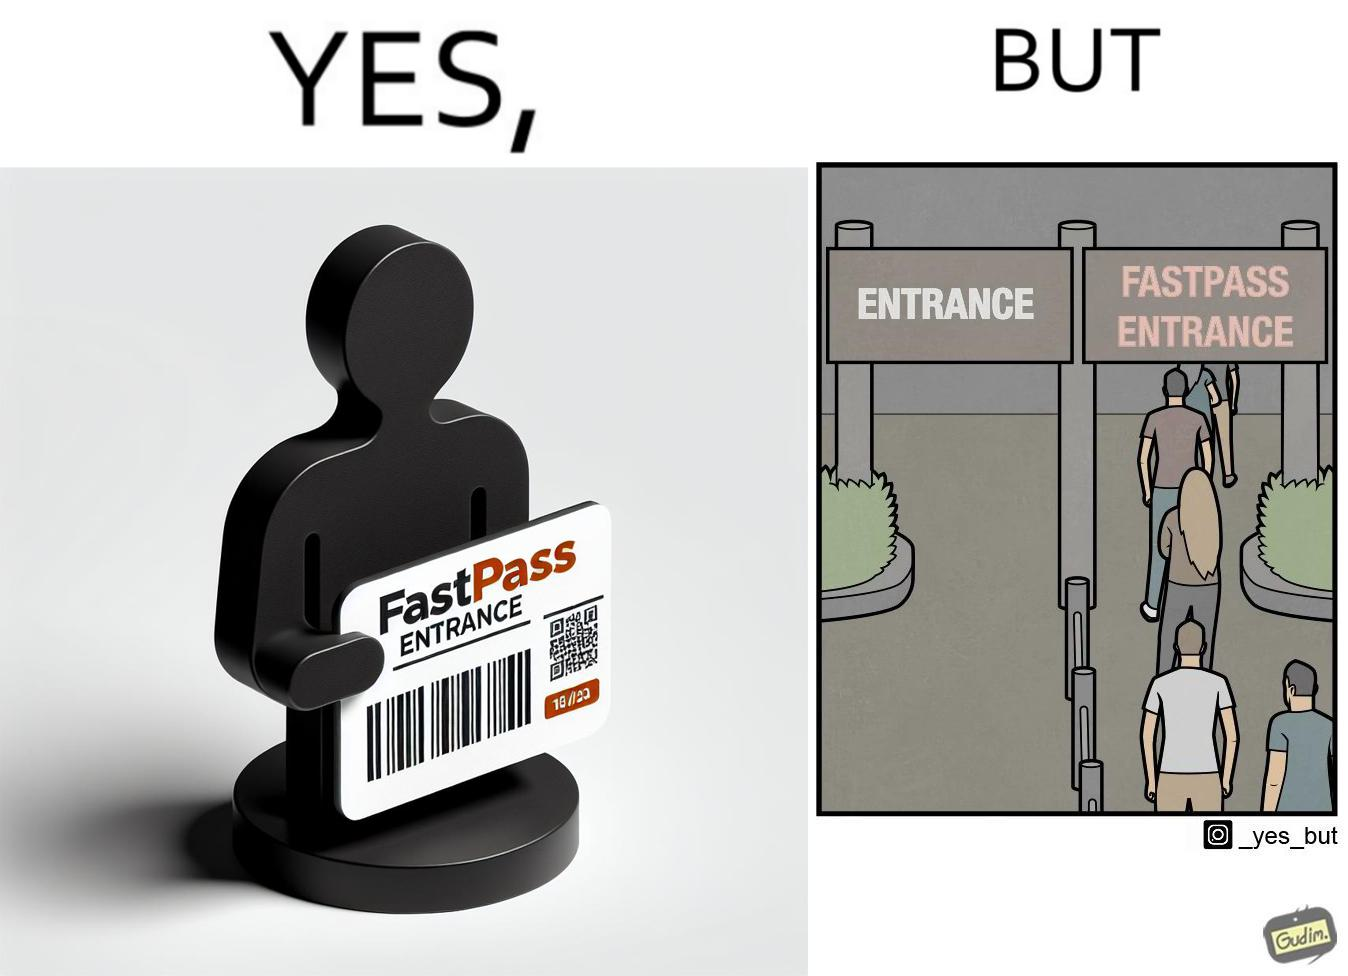What does this image depict? The image is ironic, because fast pass entrance was meant for people to pass the gate fast but as more no. of people bought the pass due to which the queue has become longer and it becomes slow and time consuming 